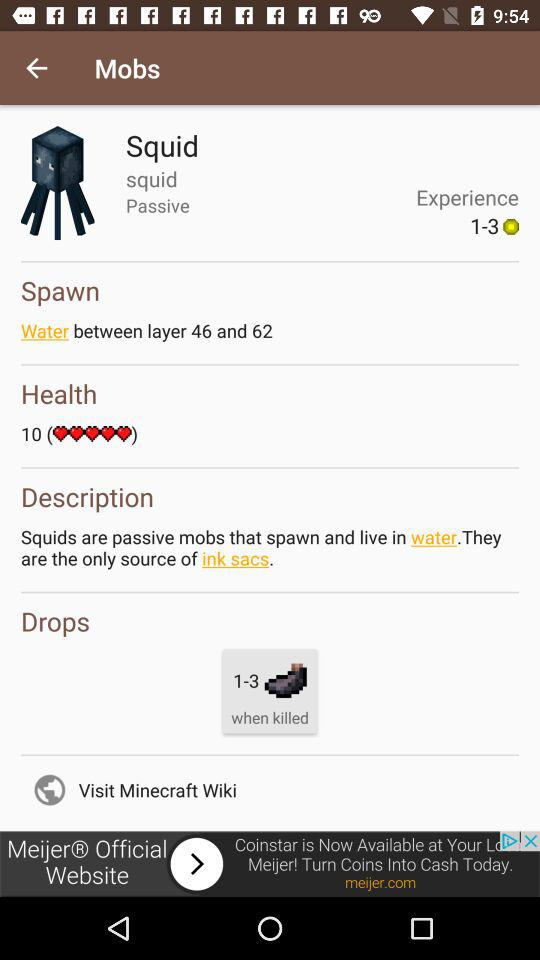What is the description? The description is: "Squids are passive mobs that spawn and live in water. They are the only source of ink sacs.". 